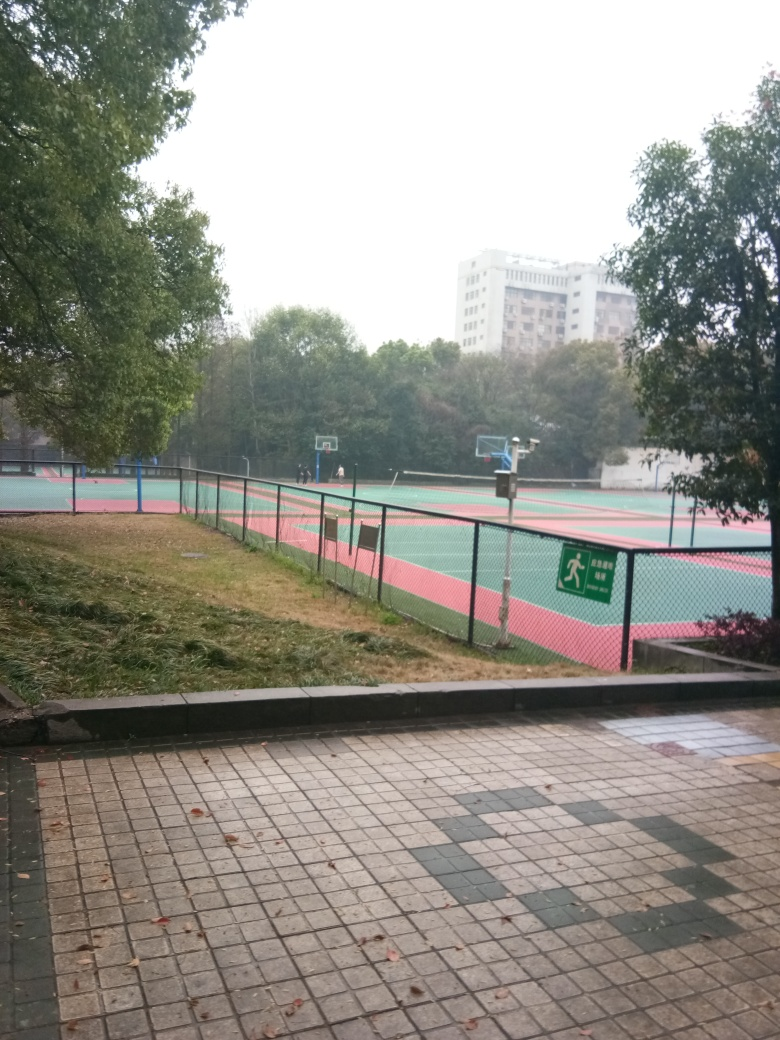Is the area well-maintained? The sports court seems to be in good condition with visible lines and colors. However, there's some debris on the ground and the corner where the curb meets the grass appears slightly eroded, suggesting some maintenance may be needed. 